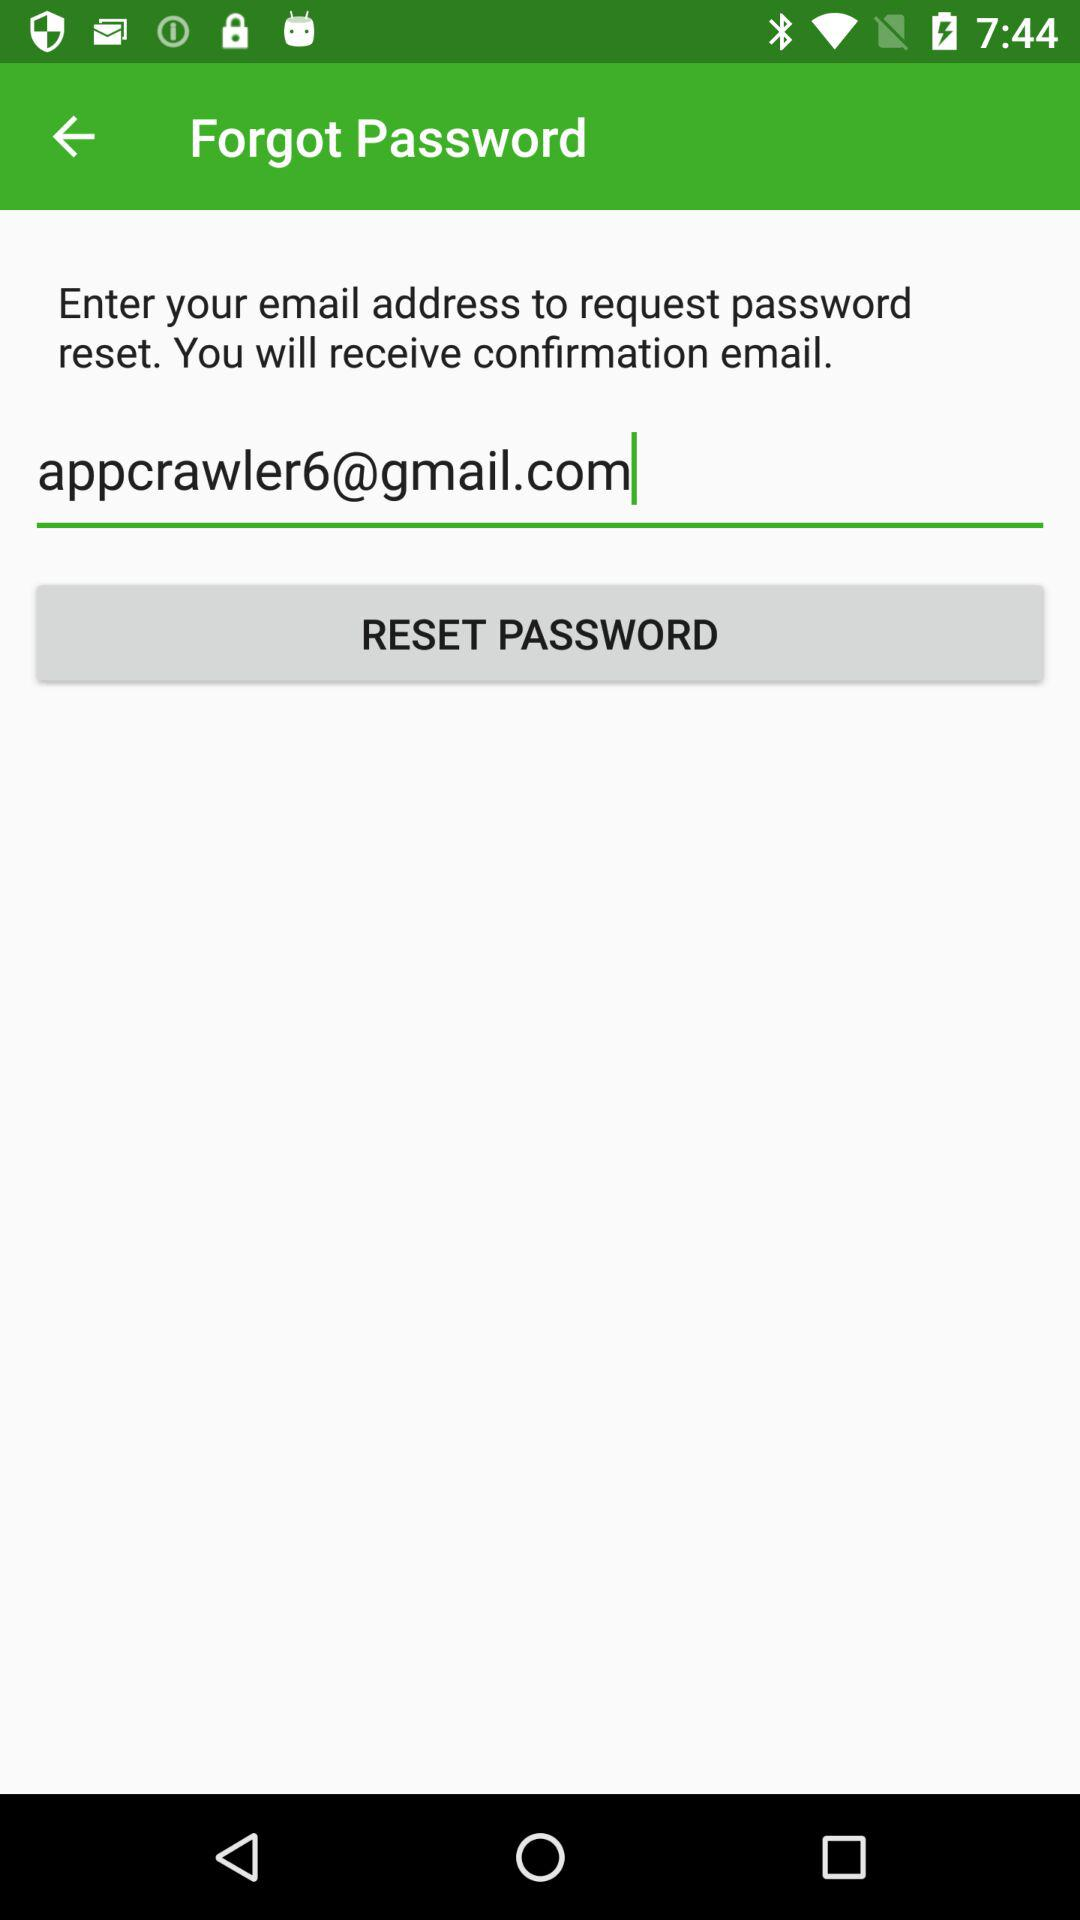What is the email address? The email address is appcrawler6@gmail.com. 